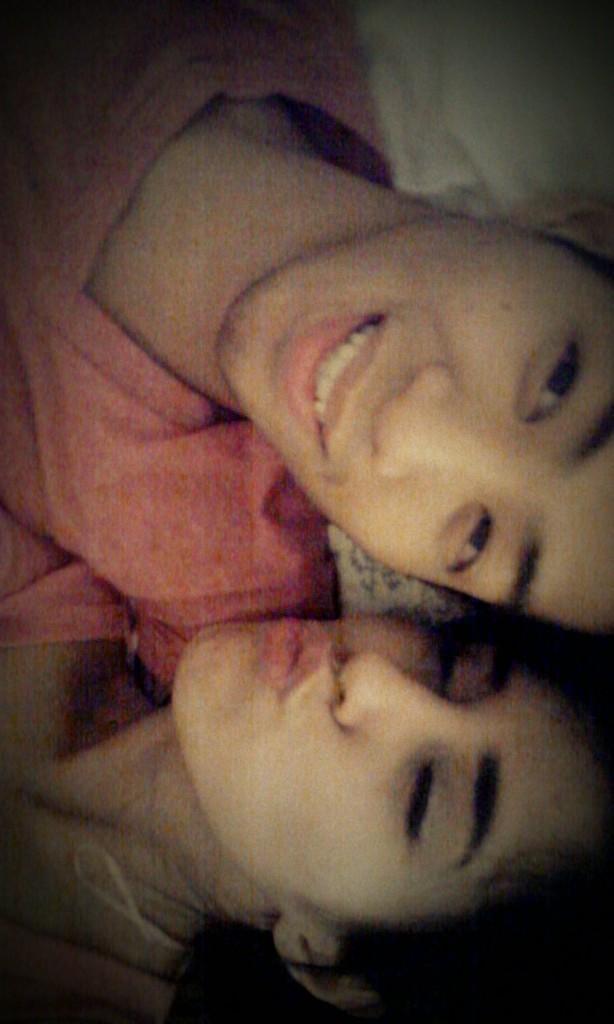Could you give a brief overview of what you see in this image? In this image we can see a man and women are wearing pink T-shirt are smiling. 